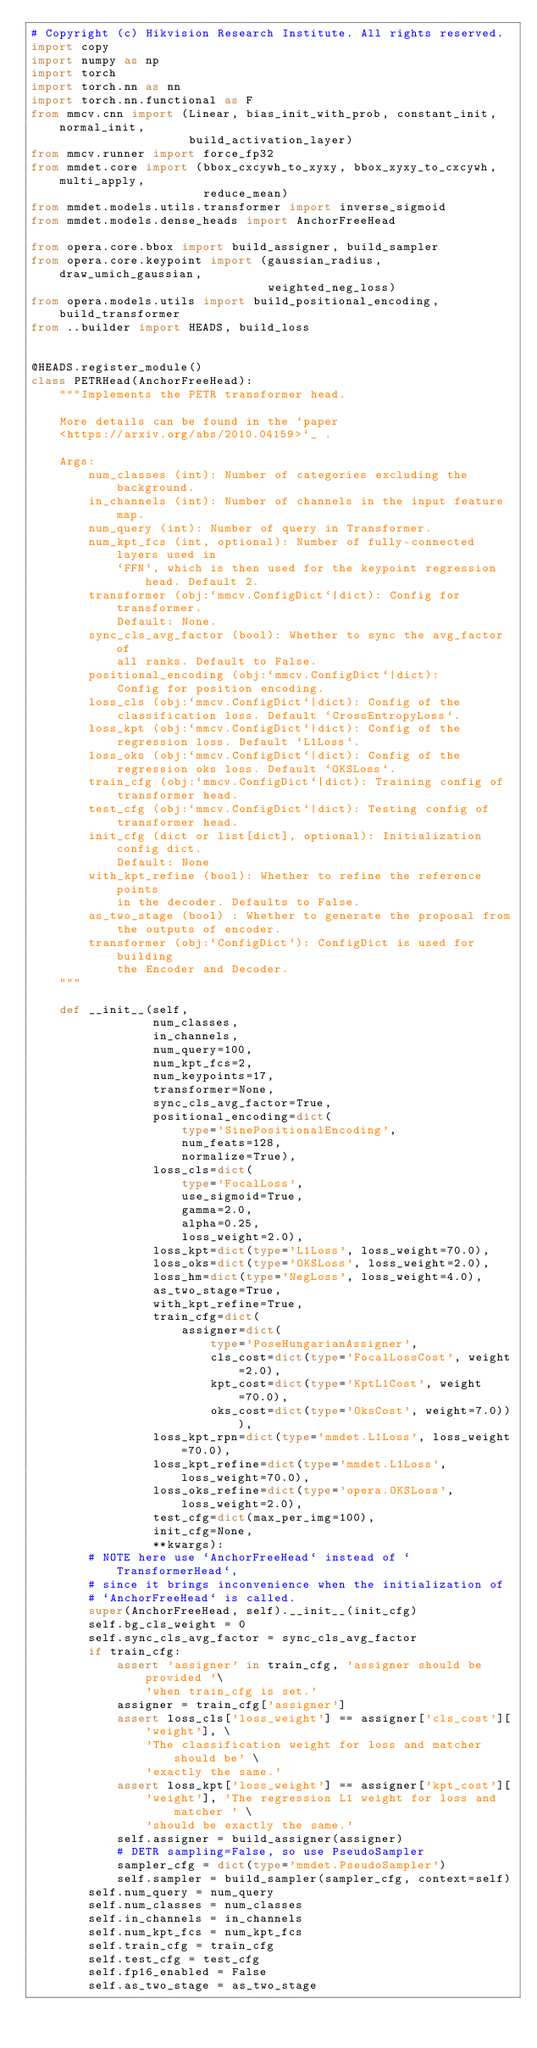<code> <loc_0><loc_0><loc_500><loc_500><_Python_># Copyright (c) Hikvision Research Institute. All rights reserved.
import copy
import numpy as np
import torch
import torch.nn as nn
import torch.nn.functional as F
from mmcv.cnn import (Linear, bias_init_with_prob, constant_init, normal_init,
                      build_activation_layer)
from mmcv.runner import force_fp32
from mmdet.core import (bbox_cxcywh_to_xyxy, bbox_xyxy_to_cxcywh, multi_apply,
                        reduce_mean)
from mmdet.models.utils.transformer import inverse_sigmoid
from mmdet.models.dense_heads import AnchorFreeHead

from opera.core.bbox import build_assigner, build_sampler
from opera.core.keypoint import (gaussian_radius, draw_umich_gaussian,
                                 weighted_neg_loss)
from opera.models.utils import build_positional_encoding, build_transformer
from ..builder import HEADS, build_loss


@HEADS.register_module()
class PETRHead(AnchorFreeHead):
    """Implements the PETR transformer head.

    More details can be found in the `paper
    <https://arxiv.org/abs/2010.04159>`_ .

    Args:
        num_classes (int): Number of categories excluding the background.
        in_channels (int): Number of channels in the input feature map.
        num_query (int): Number of query in Transformer.
        num_kpt_fcs (int, optional): Number of fully-connected layers used in
            `FFN`, which is then used for the keypoint regression head. Default 2.
        transformer (obj:`mmcv.ConfigDict`|dict): Config for transformer.
            Default: None.
        sync_cls_avg_factor (bool): Whether to sync the avg_factor of
            all ranks. Default to False.
        positional_encoding (obj:`mmcv.ConfigDict`|dict):
            Config for position encoding.
        loss_cls (obj:`mmcv.ConfigDict`|dict): Config of the
            classification loss. Default `CrossEntropyLoss`.
        loss_kpt (obj:`mmcv.ConfigDict`|dict): Config of the
            regression loss. Default `L1Loss`.
        loss_oks (obj:`mmcv.ConfigDict`|dict): Config of the
            regression oks loss. Default `OKSLoss`.
        train_cfg (obj:`mmcv.ConfigDict`|dict): Training config of
            transformer head.
        test_cfg (obj:`mmcv.ConfigDict`|dict): Testing config of
            transformer head.
        init_cfg (dict or list[dict], optional): Initialization config dict.
            Default: None
        with_kpt_refine (bool): Whether to refine the reference points
            in the decoder. Defaults to False.
        as_two_stage (bool) : Whether to generate the proposal from
            the outputs of encoder.
        transformer (obj:`ConfigDict`): ConfigDict is used for building
            the Encoder and Decoder.
    """

    def __init__(self,
                 num_classes,
                 in_channels,
                 num_query=100,
                 num_kpt_fcs=2,
                 num_keypoints=17,
                 transformer=None,
                 sync_cls_avg_factor=True,
                 positional_encoding=dict(
                     type='SinePositionalEncoding',
                     num_feats=128,
                     normalize=True),
                 loss_cls=dict(
                     type='FocalLoss',
                     use_sigmoid=True,
                     gamma=2.0,
                     alpha=0.25,
                     loss_weight=2.0),
                 loss_kpt=dict(type='L1Loss', loss_weight=70.0),
                 loss_oks=dict(type='OKSLoss', loss_weight=2.0),
                 loss_hm=dict(type='NegLoss', loss_weight=4.0),
                 as_two_stage=True,
                 with_kpt_refine=True,
                 train_cfg=dict(
                     assigner=dict(
                         type='PoseHungarianAssigner',
                         cls_cost=dict(type='FocalLossCost', weight=2.0),
                         kpt_cost=dict(type='KptL1Cost', weight=70.0),
                         oks_cost=dict(type='OksCost', weight=7.0))),
                 loss_kpt_rpn=dict(type='mmdet.L1Loss', loss_weight=70.0),
                 loss_kpt_refine=dict(type='mmdet.L1Loss', loss_weight=70.0),
                 loss_oks_refine=dict(type='opera.OKSLoss', loss_weight=2.0),
                 test_cfg=dict(max_per_img=100),
                 init_cfg=None,
                 **kwargs):
        # NOTE here use `AnchorFreeHead` instead of `TransformerHead`,
        # since it brings inconvenience when the initialization of
        # `AnchorFreeHead` is called.
        super(AnchorFreeHead, self).__init__(init_cfg)
        self.bg_cls_weight = 0
        self.sync_cls_avg_factor = sync_cls_avg_factor
        if train_cfg:
            assert 'assigner' in train_cfg, 'assigner should be provided '\
                'when train_cfg is set.'
            assigner = train_cfg['assigner']
            assert loss_cls['loss_weight'] == assigner['cls_cost']['weight'], \
                'The classification weight for loss and matcher should be' \
                'exactly the same.'
            assert loss_kpt['loss_weight'] == assigner['kpt_cost'][
                'weight'], 'The regression L1 weight for loss and matcher ' \
                'should be exactly the same.'
            self.assigner = build_assigner(assigner)
            # DETR sampling=False, so use PseudoSampler
            sampler_cfg = dict(type='mmdet.PseudoSampler')
            self.sampler = build_sampler(sampler_cfg, context=self)
        self.num_query = num_query
        self.num_classes = num_classes
        self.in_channels = in_channels
        self.num_kpt_fcs = num_kpt_fcs
        self.train_cfg = train_cfg
        self.test_cfg = test_cfg
        self.fp16_enabled = False
        self.as_two_stage = as_two_stage</code> 